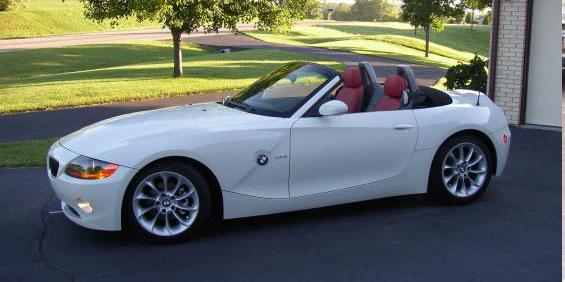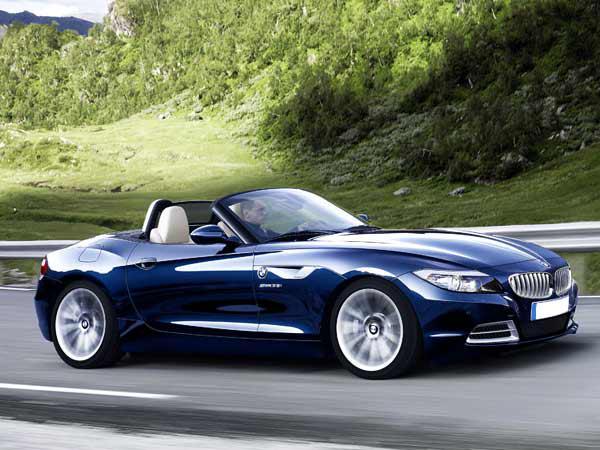The first image is the image on the left, the second image is the image on the right. Analyze the images presented: Is the assertion "The left image contains a white convertible that is parked facing towards the left." valid? Answer yes or no. Yes. The first image is the image on the left, the second image is the image on the right. Evaluate the accuracy of this statement regarding the images: "One of the cars is facing the left and has red seats while the other car faces the right and has beige seats.". Is it true? Answer yes or no. Yes. 